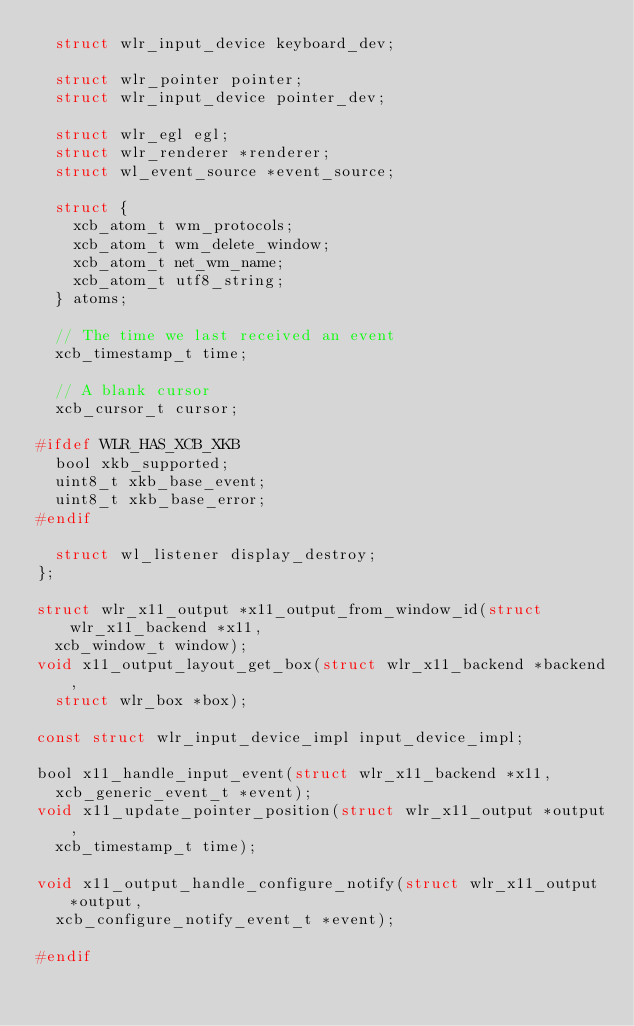Convert code to text. <code><loc_0><loc_0><loc_500><loc_500><_C_>	struct wlr_input_device keyboard_dev;

	struct wlr_pointer pointer;
	struct wlr_input_device pointer_dev;

	struct wlr_egl egl;
	struct wlr_renderer *renderer;
	struct wl_event_source *event_source;

	struct {
		xcb_atom_t wm_protocols;
		xcb_atom_t wm_delete_window;
		xcb_atom_t net_wm_name;
		xcb_atom_t utf8_string;
	} atoms;

	// The time we last received an event
	xcb_timestamp_t time;

	// A blank cursor
	xcb_cursor_t cursor;

#ifdef WLR_HAS_XCB_XKB
	bool xkb_supported;
	uint8_t xkb_base_event;
	uint8_t xkb_base_error;
#endif

	struct wl_listener display_destroy;
};

struct wlr_x11_output *x11_output_from_window_id(struct wlr_x11_backend *x11,
	xcb_window_t window);
void x11_output_layout_get_box(struct wlr_x11_backend *backend,
	struct wlr_box *box);

const struct wlr_input_device_impl input_device_impl;

bool x11_handle_input_event(struct wlr_x11_backend *x11,
	xcb_generic_event_t *event);
void x11_update_pointer_position(struct wlr_x11_output *output,
	xcb_timestamp_t time);

void x11_output_handle_configure_notify(struct wlr_x11_output *output,
	xcb_configure_notify_event_t *event);

#endif
</code> 